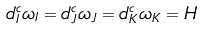<formula> <loc_0><loc_0><loc_500><loc_500>d ^ { c } _ { I } \omega _ { I } = d ^ { c } _ { J } \omega _ { J } = d ^ { c } _ { K } \omega _ { K } = H</formula> 